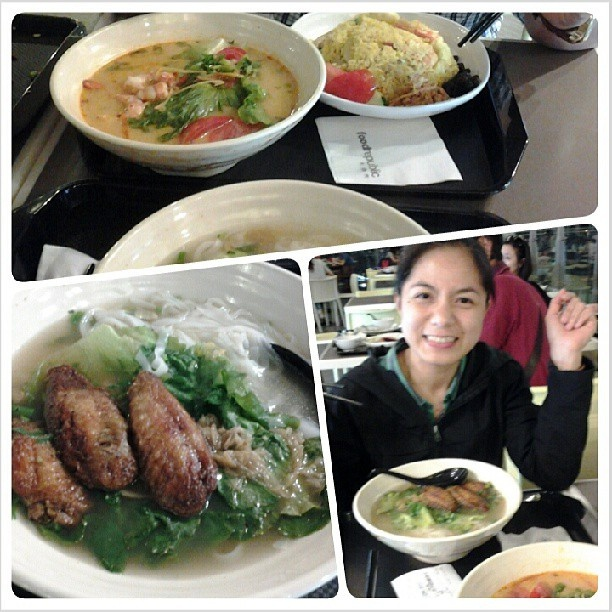Describe the objects in this image and their specific colors. I can see people in lightgray, black, lightpink, and tan tones, bowl in lightgray, tan, darkgray, and olive tones, bowl in lightgray, darkgray, beige, and tan tones, bowl in lightgray, ivory, olive, darkgray, and beige tones, and bowl in lightgray, beige, and tan tones in this image. 